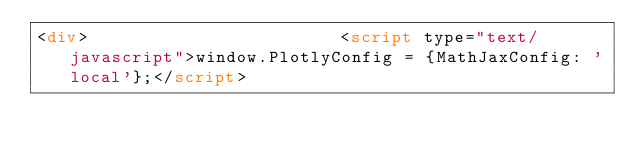Convert code to text. <code><loc_0><loc_0><loc_500><loc_500><_HTML_><div>                        <script type="text/javascript">window.PlotlyConfig = {MathJaxConfig: 'local'};</script></code> 